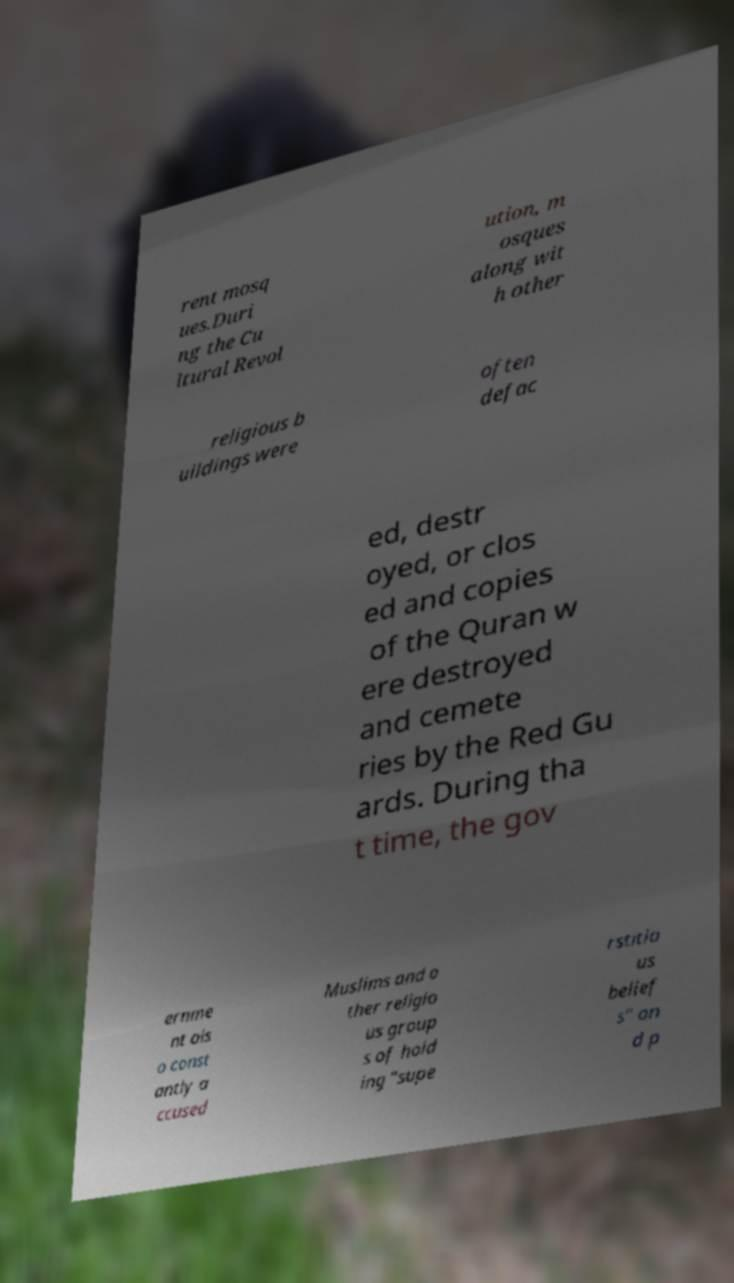Could you assist in decoding the text presented in this image and type it out clearly? rent mosq ues.Duri ng the Cu ltural Revol ution, m osques along wit h other religious b uildings were often defac ed, destr oyed, or clos ed and copies of the Quran w ere destroyed and cemete ries by the Red Gu ards. During tha t time, the gov ernme nt als o const antly a ccused Muslims and o ther religio us group s of hold ing "supe rstitio us belief s" an d p 